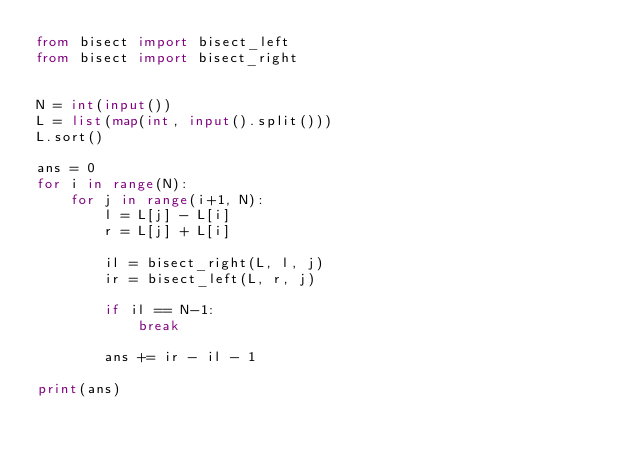<code> <loc_0><loc_0><loc_500><loc_500><_Python_>from bisect import bisect_left
from bisect import bisect_right


N = int(input())
L = list(map(int, input().split()))
L.sort()

ans = 0
for i in range(N):
    for j in range(i+1, N):
        l = L[j] - L[i]
        r = L[j] + L[i]

        il = bisect_right(L, l, j)
        ir = bisect_left(L, r, j)

        if il == N-1:
            break

        ans += ir - il - 1

print(ans)</code> 